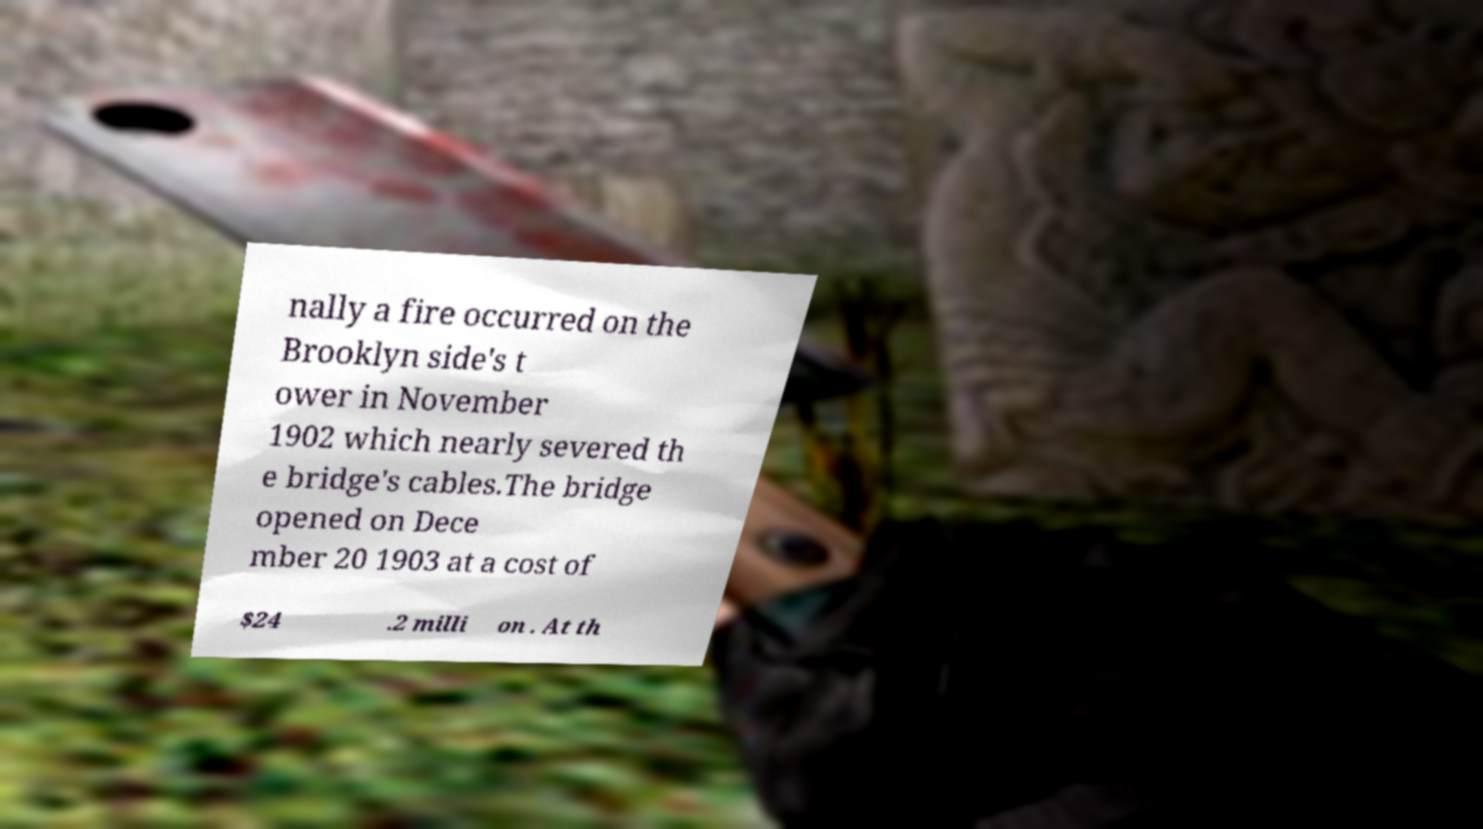For documentation purposes, I need the text within this image transcribed. Could you provide that? nally a fire occurred on the Brooklyn side's t ower in November 1902 which nearly severed th e bridge's cables.The bridge opened on Dece mber 20 1903 at a cost of $24 .2 milli on . At th 